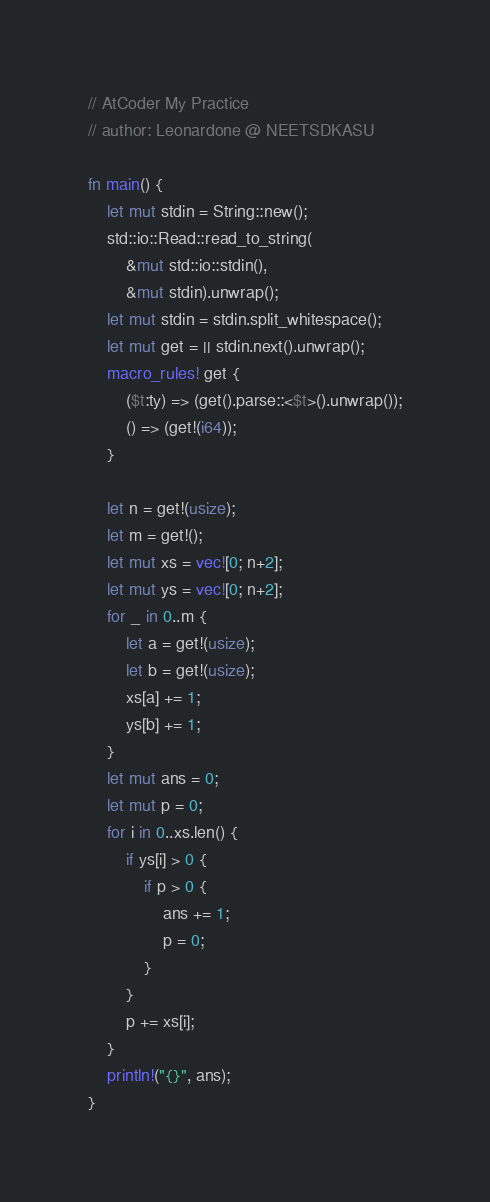Convert code to text. <code><loc_0><loc_0><loc_500><loc_500><_Rust_>// AtCoder My Practice
// author: Leonardone @ NEETSDKASU

fn main() {
	let mut stdin = String::new();
    std::io::Read::read_to_string(
    	&mut std::io::stdin(),
        &mut stdin).unwrap();
	let mut stdin = stdin.split_whitespace();
    let mut get = || stdin.next().unwrap();
    macro_rules! get {
    	($t:ty) => (get().parse::<$t>().unwrap());
        () => (get!(i64));
    }
    
    let n = get!(usize);
    let m = get!();
    let mut xs = vec![0; n+2];
    let mut ys = vec![0; n+2];
    for _ in 0..m {
    	let a = get!(usize);
        let b = get!(usize);
        xs[a] += 1;
        ys[b] += 1;
    }
    let mut ans = 0;
    let mut p = 0;
    for i in 0..xs.len() {
    	if ys[i] > 0 {
        	if p > 0 {
        		ans += 1;
                p = 0;
			}
        }
        p += xs[i];
    }
    println!("{}", ans);
}
</code> 